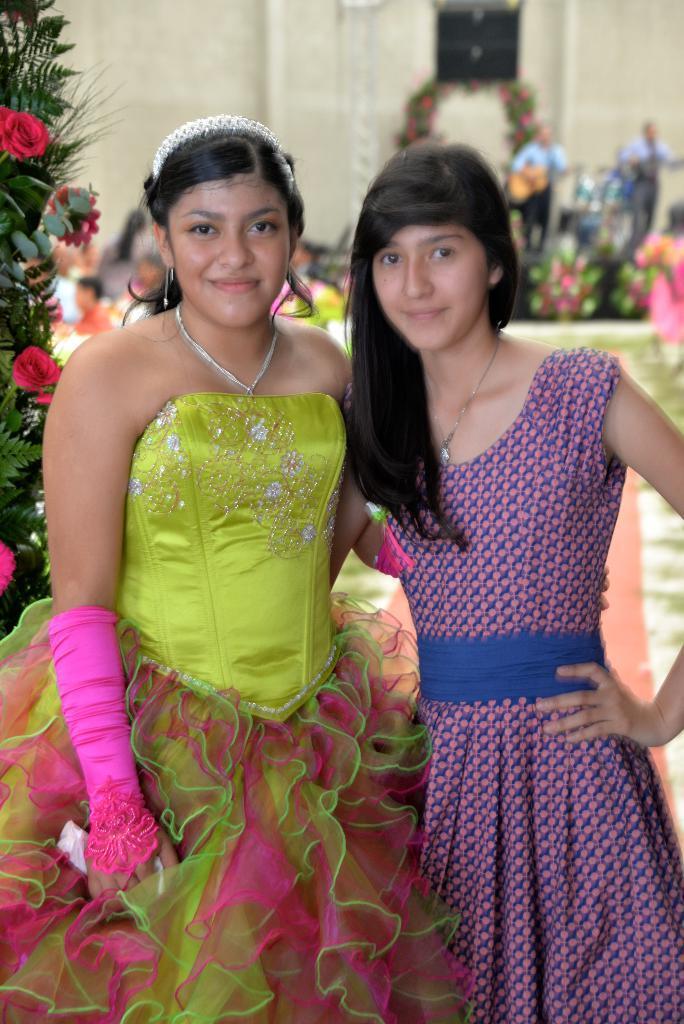Please provide a concise description of this image. In this image we can see two girls. Girl on the left side is wearing gloves. In the back there is a tree with flowers. In the background it is looking blur and there are some decorations. Also we can see a person holding a guitar. And there is a wall. 